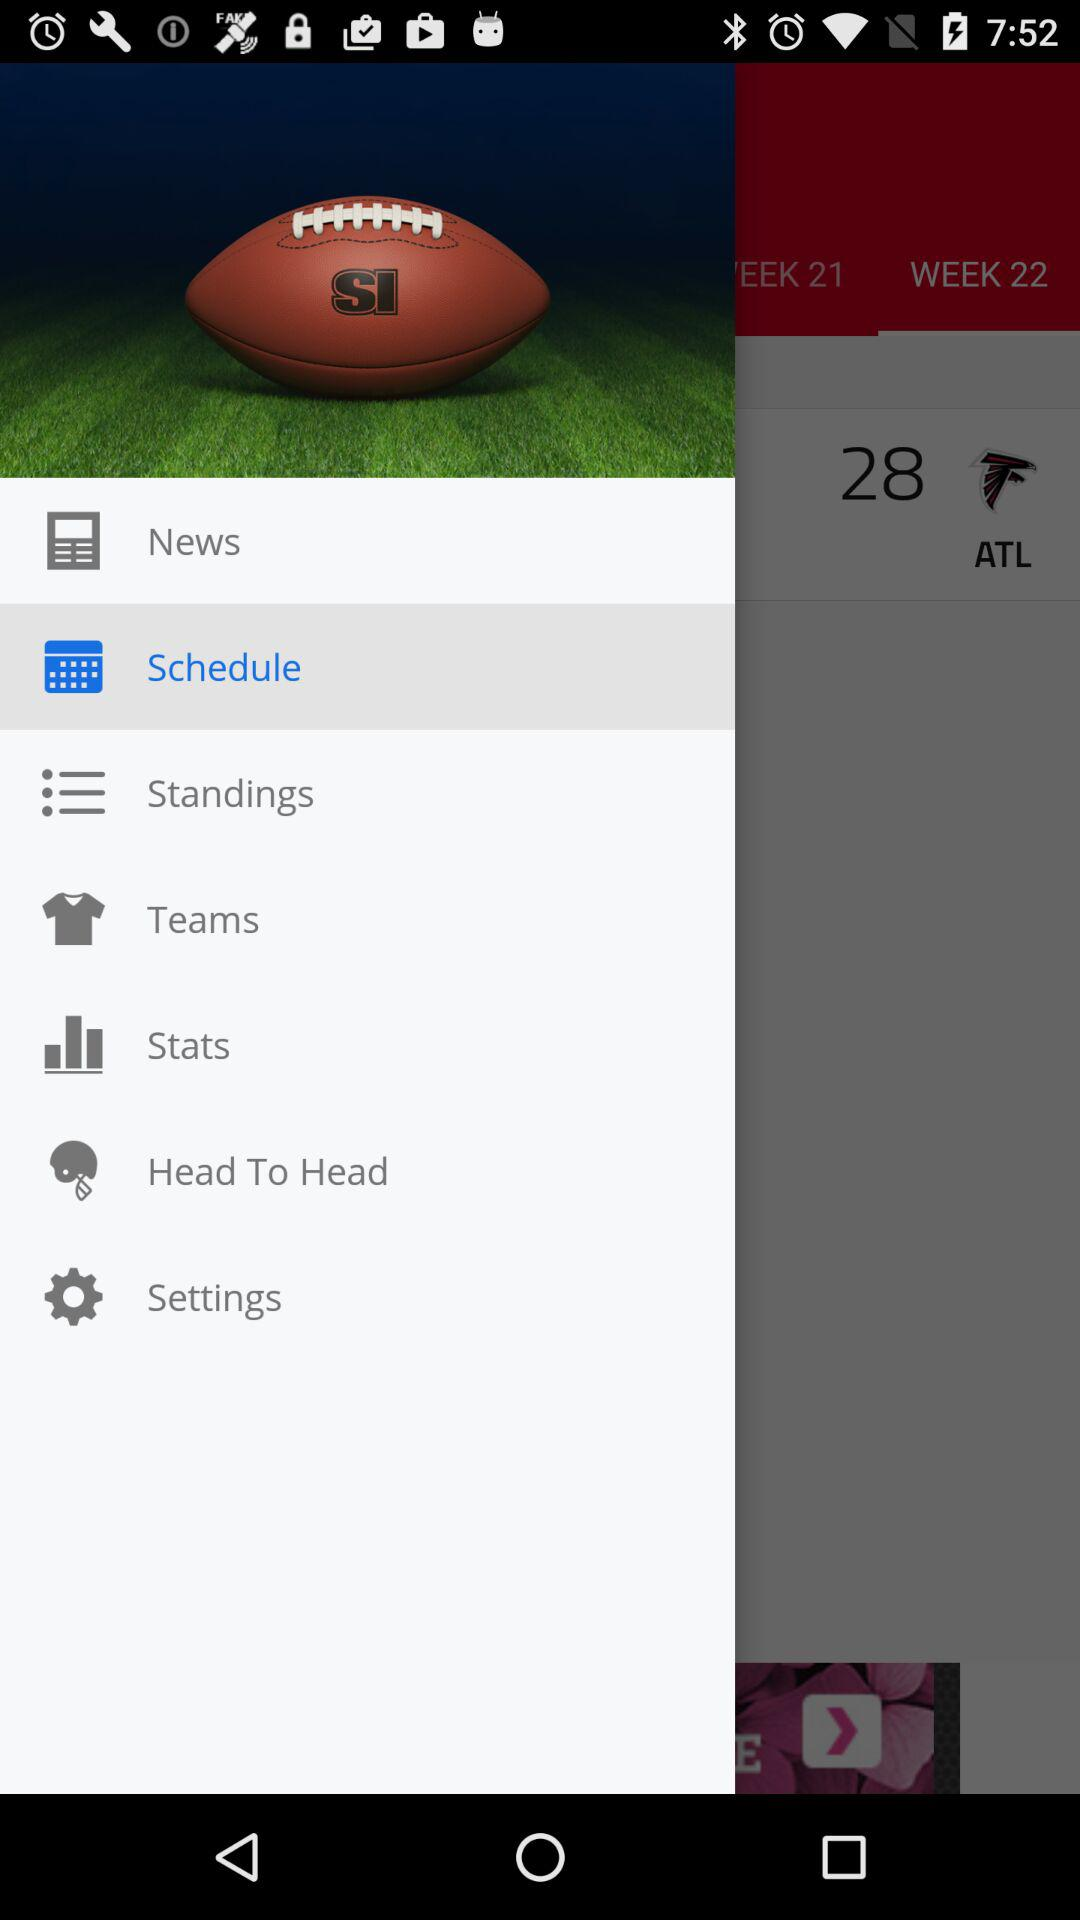Which option is selected? The selected option is "Schedule". 